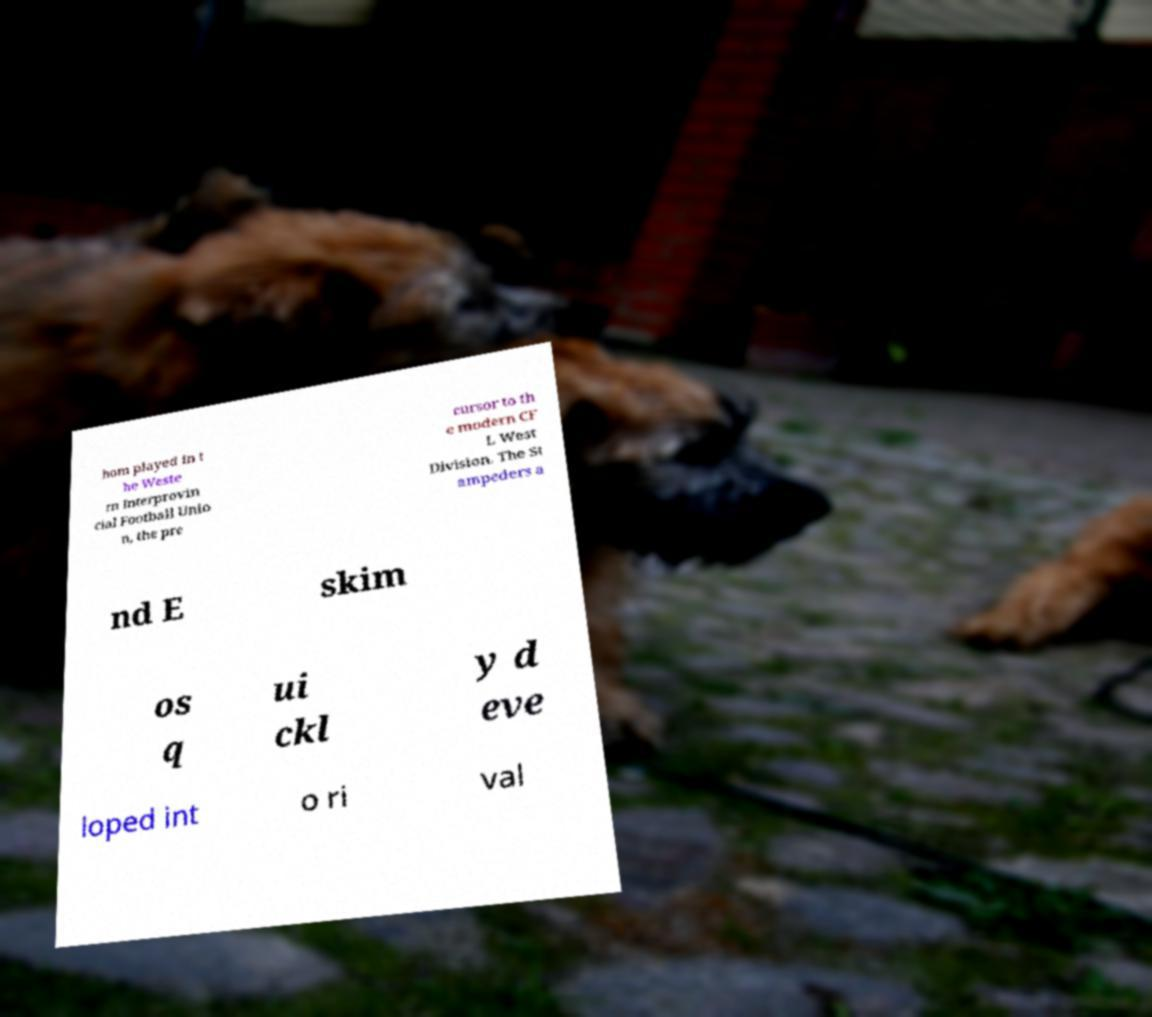Can you accurately transcribe the text from the provided image for me? hom played in t he Weste rn Interprovin cial Football Unio n, the pre cursor to th e modern CF L West Division. The St ampeders a nd E skim os q ui ckl y d eve loped int o ri val 